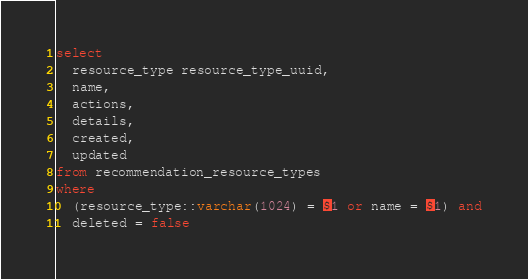Convert code to text. <code><loc_0><loc_0><loc_500><loc_500><_SQL_>select
  resource_type resource_type_uuid,
  name,
  actions,
  details,
  created,
  updated
from recommendation_resource_types
where 
  (resource_type::varchar(1024) = $1 or name = $1) and
  deleted = false</code> 